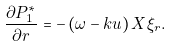<formula> <loc_0><loc_0><loc_500><loc_500>\frac { \partial P _ { 1 } ^ { \ast } } { \partial r } = - \left ( \omega - k u \right ) X \xi _ { r } .</formula> 